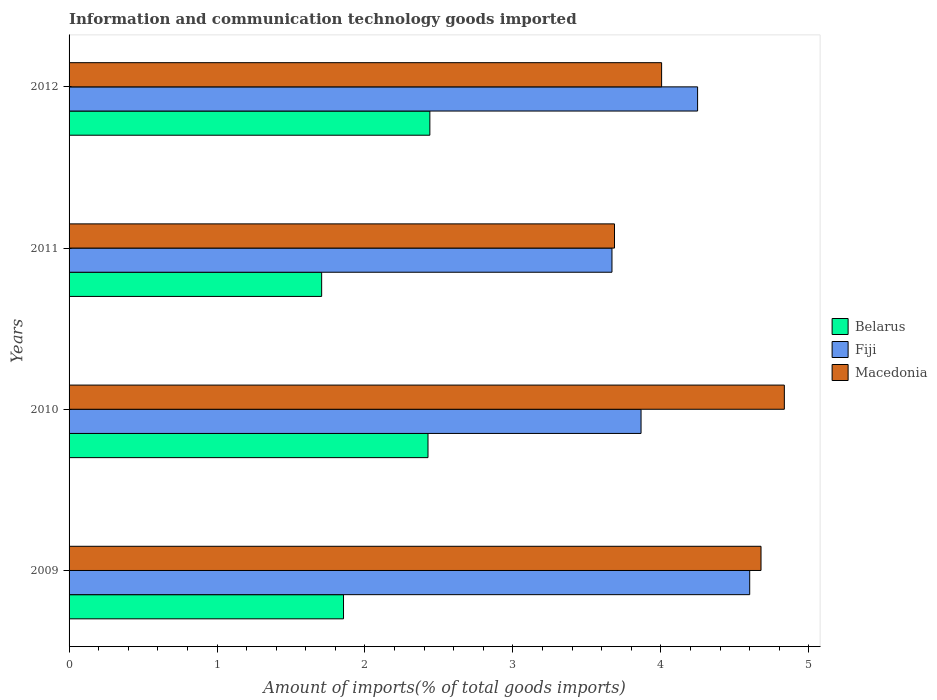How many different coloured bars are there?
Offer a terse response. 3. How many groups of bars are there?
Your response must be concise. 4. Are the number of bars per tick equal to the number of legend labels?
Your response must be concise. Yes. Are the number of bars on each tick of the Y-axis equal?
Give a very brief answer. Yes. What is the label of the 2nd group of bars from the top?
Ensure brevity in your answer.  2011. In how many cases, is the number of bars for a given year not equal to the number of legend labels?
Your answer should be compact. 0. What is the amount of goods imported in Fiji in 2010?
Your response must be concise. 3.87. Across all years, what is the maximum amount of goods imported in Fiji?
Offer a very short reply. 4.6. Across all years, what is the minimum amount of goods imported in Fiji?
Your answer should be compact. 3.67. In which year was the amount of goods imported in Fiji maximum?
Keep it short and to the point. 2009. What is the total amount of goods imported in Macedonia in the graph?
Ensure brevity in your answer.  17.2. What is the difference between the amount of goods imported in Fiji in 2009 and that in 2010?
Your answer should be compact. 0.73. What is the difference between the amount of goods imported in Macedonia in 2009 and the amount of goods imported in Fiji in 2011?
Your response must be concise. 1.01. What is the average amount of goods imported in Fiji per year?
Provide a succinct answer. 4.1. In the year 2010, what is the difference between the amount of goods imported in Fiji and amount of goods imported in Belarus?
Make the answer very short. 1.44. What is the ratio of the amount of goods imported in Belarus in 2011 to that in 2012?
Keep it short and to the point. 0.7. Is the amount of goods imported in Belarus in 2011 less than that in 2012?
Your answer should be compact. Yes. What is the difference between the highest and the second highest amount of goods imported in Fiji?
Give a very brief answer. 0.35. What is the difference between the highest and the lowest amount of goods imported in Fiji?
Ensure brevity in your answer.  0.93. What does the 1st bar from the top in 2011 represents?
Offer a terse response. Macedonia. What does the 2nd bar from the bottom in 2010 represents?
Keep it short and to the point. Fiji. How many bars are there?
Your answer should be compact. 12. How many years are there in the graph?
Your answer should be compact. 4. Does the graph contain any zero values?
Your response must be concise. No. Does the graph contain grids?
Your answer should be compact. No. What is the title of the graph?
Provide a succinct answer. Information and communication technology goods imported. What is the label or title of the X-axis?
Your response must be concise. Amount of imports(% of total goods imports). What is the label or title of the Y-axis?
Provide a succinct answer. Years. What is the Amount of imports(% of total goods imports) in Belarus in 2009?
Your response must be concise. 1.85. What is the Amount of imports(% of total goods imports) of Fiji in 2009?
Ensure brevity in your answer.  4.6. What is the Amount of imports(% of total goods imports) of Macedonia in 2009?
Ensure brevity in your answer.  4.68. What is the Amount of imports(% of total goods imports) of Belarus in 2010?
Offer a terse response. 2.43. What is the Amount of imports(% of total goods imports) in Fiji in 2010?
Offer a terse response. 3.87. What is the Amount of imports(% of total goods imports) in Macedonia in 2010?
Provide a short and direct response. 4.83. What is the Amount of imports(% of total goods imports) of Belarus in 2011?
Ensure brevity in your answer.  1.71. What is the Amount of imports(% of total goods imports) of Fiji in 2011?
Offer a very short reply. 3.67. What is the Amount of imports(% of total goods imports) in Macedonia in 2011?
Ensure brevity in your answer.  3.69. What is the Amount of imports(% of total goods imports) in Belarus in 2012?
Make the answer very short. 2.44. What is the Amount of imports(% of total goods imports) of Fiji in 2012?
Offer a very short reply. 4.25. What is the Amount of imports(% of total goods imports) of Macedonia in 2012?
Provide a short and direct response. 4. Across all years, what is the maximum Amount of imports(% of total goods imports) of Belarus?
Provide a short and direct response. 2.44. Across all years, what is the maximum Amount of imports(% of total goods imports) of Fiji?
Give a very brief answer. 4.6. Across all years, what is the maximum Amount of imports(% of total goods imports) in Macedonia?
Your answer should be very brief. 4.83. Across all years, what is the minimum Amount of imports(% of total goods imports) of Belarus?
Provide a succinct answer. 1.71. Across all years, what is the minimum Amount of imports(% of total goods imports) of Fiji?
Provide a succinct answer. 3.67. Across all years, what is the minimum Amount of imports(% of total goods imports) in Macedonia?
Provide a short and direct response. 3.69. What is the total Amount of imports(% of total goods imports) in Belarus in the graph?
Provide a short and direct response. 8.43. What is the total Amount of imports(% of total goods imports) in Fiji in the graph?
Your answer should be very brief. 16.38. What is the total Amount of imports(% of total goods imports) in Macedonia in the graph?
Provide a short and direct response. 17.2. What is the difference between the Amount of imports(% of total goods imports) in Belarus in 2009 and that in 2010?
Make the answer very short. -0.57. What is the difference between the Amount of imports(% of total goods imports) of Fiji in 2009 and that in 2010?
Keep it short and to the point. 0.73. What is the difference between the Amount of imports(% of total goods imports) in Macedonia in 2009 and that in 2010?
Your answer should be compact. -0.16. What is the difference between the Amount of imports(% of total goods imports) of Belarus in 2009 and that in 2011?
Keep it short and to the point. 0.15. What is the difference between the Amount of imports(% of total goods imports) of Fiji in 2009 and that in 2011?
Offer a very short reply. 0.93. What is the difference between the Amount of imports(% of total goods imports) of Macedonia in 2009 and that in 2011?
Offer a terse response. 0.99. What is the difference between the Amount of imports(% of total goods imports) of Belarus in 2009 and that in 2012?
Your answer should be compact. -0.58. What is the difference between the Amount of imports(% of total goods imports) of Fiji in 2009 and that in 2012?
Make the answer very short. 0.35. What is the difference between the Amount of imports(% of total goods imports) of Macedonia in 2009 and that in 2012?
Your answer should be compact. 0.67. What is the difference between the Amount of imports(% of total goods imports) in Belarus in 2010 and that in 2011?
Keep it short and to the point. 0.72. What is the difference between the Amount of imports(% of total goods imports) of Fiji in 2010 and that in 2011?
Offer a terse response. 0.2. What is the difference between the Amount of imports(% of total goods imports) of Macedonia in 2010 and that in 2011?
Offer a terse response. 1.15. What is the difference between the Amount of imports(% of total goods imports) of Belarus in 2010 and that in 2012?
Provide a short and direct response. -0.01. What is the difference between the Amount of imports(% of total goods imports) in Fiji in 2010 and that in 2012?
Provide a short and direct response. -0.38. What is the difference between the Amount of imports(% of total goods imports) in Macedonia in 2010 and that in 2012?
Offer a terse response. 0.83. What is the difference between the Amount of imports(% of total goods imports) of Belarus in 2011 and that in 2012?
Your response must be concise. -0.73. What is the difference between the Amount of imports(% of total goods imports) in Fiji in 2011 and that in 2012?
Offer a terse response. -0.58. What is the difference between the Amount of imports(% of total goods imports) of Macedonia in 2011 and that in 2012?
Offer a very short reply. -0.32. What is the difference between the Amount of imports(% of total goods imports) of Belarus in 2009 and the Amount of imports(% of total goods imports) of Fiji in 2010?
Provide a short and direct response. -2.01. What is the difference between the Amount of imports(% of total goods imports) in Belarus in 2009 and the Amount of imports(% of total goods imports) in Macedonia in 2010?
Ensure brevity in your answer.  -2.98. What is the difference between the Amount of imports(% of total goods imports) in Fiji in 2009 and the Amount of imports(% of total goods imports) in Macedonia in 2010?
Your response must be concise. -0.23. What is the difference between the Amount of imports(% of total goods imports) of Belarus in 2009 and the Amount of imports(% of total goods imports) of Fiji in 2011?
Offer a very short reply. -1.81. What is the difference between the Amount of imports(% of total goods imports) in Belarus in 2009 and the Amount of imports(% of total goods imports) in Macedonia in 2011?
Your response must be concise. -1.83. What is the difference between the Amount of imports(% of total goods imports) in Fiji in 2009 and the Amount of imports(% of total goods imports) in Macedonia in 2011?
Ensure brevity in your answer.  0.91. What is the difference between the Amount of imports(% of total goods imports) of Belarus in 2009 and the Amount of imports(% of total goods imports) of Fiji in 2012?
Offer a terse response. -2.39. What is the difference between the Amount of imports(% of total goods imports) of Belarus in 2009 and the Amount of imports(% of total goods imports) of Macedonia in 2012?
Your answer should be very brief. -2.15. What is the difference between the Amount of imports(% of total goods imports) in Fiji in 2009 and the Amount of imports(% of total goods imports) in Macedonia in 2012?
Ensure brevity in your answer.  0.6. What is the difference between the Amount of imports(% of total goods imports) of Belarus in 2010 and the Amount of imports(% of total goods imports) of Fiji in 2011?
Ensure brevity in your answer.  -1.24. What is the difference between the Amount of imports(% of total goods imports) in Belarus in 2010 and the Amount of imports(% of total goods imports) in Macedonia in 2011?
Provide a short and direct response. -1.26. What is the difference between the Amount of imports(% of total goods imports) of Fiji in 2010 and the Amount of imports(% of total goods imports) of Macedonia in 2011?
Offer a terse response. 0.18. What is the difference between the Amount of imports(% of total goods imports) in Belarus in 2010 and the Amount of imports(% of total goods imports) in Fiji in 2012?
Offer a very short reply. -1.82. What is the difference between the Amount of imports(% of total goods imports) in Belarus in 2010 and the Amount of imports(% of total goods imports) in Macedonia in 2012?
Your response must be concise. -1.58. What is the difference between the Amount of imports(% of total goods imports) of Fiji in 2010 and the Amount of imports(% of total goods imports) of Macedonia in 2012?
Offer a very short reply. -0.14. What is the difference between the Amount of imports(% of total goods imports) in Belarus in 2011 and the Amount of imports(% of total goods imports) in Fiji in 2012?
Ensure brevity in your answer.  -2.54. What is the difference between the Amount of imports(% of total goods imports) in Belarus in 2011 and the Amount of imports(% of total goods imports) in Macedonia in 2012?
Provide a short and direct response. -2.3. What is the difference between the Amount of imports(% of total goods imports) in Fiji in 2011 and the Amount of imports(% of total goods imports) in Macedonia in 2012?
Provide a succinct answer. -0.34. What is the average Amount of imports(% of total goods imports) of Belarus per year?
Provide a short and direct response. 2.11. What is the average Amount of imports(% of total goods imports) in Fiji per year?
Offer a very short reply. 4.1. What is the average Amount of imports(% of total goods imports) of Macedonia per year?
Make the answer very short. 4.3. In the year 2009, what is the difference between the Amount of imports(% of total goods imports) in Belarus and Amount of imports(% of total goods imports) in Fiji?
Your response must be concise. -2.75. In the year 2009, what is the difference between the Amount of imports(% of total goods imports) in Belarus and Amount of imports(% of total goods imports) in Macedonia?
Ensure brevity in your answer.  -2.82. In the year 2009, what is the difference between the Amount of imports(% of total goods imports) of Fiji and Amount of imports(% of total goods imports) of Macedonia?
Provide a succinct answer. -0.08. In the year 2010, what is the difference between the Amount of imports(% of total goods imports) in Belarus and Amount of imports(% of total goods imports) in Fiji?
Provide a short and direct response. -1.44. In the year 2010, what is the difference between the Amount of imports(% of total goods imports) in Belarus and Amount of imports(% of total goods imports) in Macedonia?
Your answer should be compact. -2.41. In the year 2010, what is the difference between the Amount of imports(% of total goods imports) of Fiji and Amount of imports(% of total goods imports) of Macedonia?
Make the answer very short. -0.97. In the year 2011, what is the difference between the Amount of imports(% of total goods imports) in Belarus and Amount of imports(% of total goods imports) in Fiji?
Your answer should be very brief. -1.96. In the year 2011, what is the difference between the Amount of imports(% of total goods imports) in Belarus and Amount of imports(% of total goods imports) in Macedonia?
Offer a very short reply. -1.98. In the year 2011, what is the difference between the Amount of imports(% of total goods imports) of Fiji and Amount of imports(% of total goods imports) of Macedonia?
Make the answer very short. -0.02. In the year 2012, what is the difference between the Amount of imports(% of total goods imports) of Belarus and Amount of imports(% of total goods imports) of Fiji?
Provide a succinct answer. -1.81. In the year 2012, what is the difference between the Amount of imports(% of total goods imports) of Belarus and Amount of imports(% of total goods imports) of Macedonia?
Provide a short and direct response. -1.57. In the year 2012, what is the difference between the Amount of imports(% of total goods imports) of Fiji and Amount of imports(% of total goods imports) of Macedonia?
Offer a terse response. 0.24. What is the ratio of the Amount of imports(% of total goods imports) in Belarus in 2009 to that in 2010?
Offer a very short reply. 0.76. What is the ratio of the Amount of imports(% of total goods imports) of Fiji in 2009 to that in 2010?
Make the answer very short. 1.19. What is the ratio of the Amount of imports(% of total goods imports) in Macedonia in 2009 to that in 2010?
Keep it short and to the point. 0.97. What is the ratio of the Amount of imports(% of total goods imports) of Belarus in 2009 to that in 2011?
Provide a succinct answer. 1.09. What is the ratio of the Amount of imports(% of total goods imports) in Fiji in 2009 to that in 2011?
Offer a very short reply. 1.25. What is the ratio of the Amount of imports(% of total goods imports) in Macedonia in 2009 to that in 2011?
Offer a very short reply. 1.27. What is the ratio of the Amount of imports(% of total goods imports) of Belarus in 2009 to that in 2012?
Keep it short and to the point. 0.76. What is the ratio of the Amount of imports(% of total goods imports) of Fiji in 2009 to that in 2012?
Offer a terse response. 1.08. What is the ratio of the Amount of imports(% of total goods imports) of Macedonia in 2009 to that in 2012?
Your answer should be very brief. 1.17. What is the ratio of the Amount of imports(% of total goods imports) of Belarus in 2010 to that in 2011?
Provide a succinct answer. 1.42. What is the ratio of the Amount of imports(% of total goods imports) of Fiji in 2010 to that in 2011?
Ensure brevity in your answer.  1.05. What is the ratio of the Amount of imports(% of total goods imports) in Macedonia in 2010 to that in 2011?
Give a very brief answer. 1.31. What is the ratio of the Amount of imports(% of total goods imports) in Fiji in 2010 to that in 2012?
Ensure brevity in your answer.  0.91. What is the ratio of the Amount of imports(% of total goods imports) in Macedonia in 2010 to that in 2012?
Your response must be concise. 1.21. What is the ratio of the Amount of imports(% of total goods imports) in Belarus in 2011 to that in 2012?
Give a very brief answer. 0.7. What is the ratio of the Amount of imports(% of total goods imports) in Fiji in 2011 to that in 2012?
Your answer should be compact. 0.86. What is the ratio of the Amount of imports(% of total goods imports) in Macedonia in 2011 to that in 2012?
Provide a succinct answer. 0.92. What is the difference between the highest and the second highest Amount of imports(% of total goods imports) of Belarus?
Give a very brief answer. 0.01. What is the difference between the highest and the second highest Amount of imports(% of total goods imports) of Fiji?
Your answer should be very brief. 0.35. What is the difference between the highest and the second highest Amount of imports(% of total goods imports) of Macedonia?
Your response must be concise. 0.16. What is the difference between the highest and the lowest Amount of imports(% of total goods imports) of Belarus?
Give a very brief answer. 0.73. What is the difference between the highest and the lowest Amount of imports(% of total goods imports) of Fiji?
Ensure brevity in your answer.  0.93. What is the difference between the highest and the lowest Amount of imports(% of total goods imports) in Macedonia?
Offer a very short reply. 1.15. 